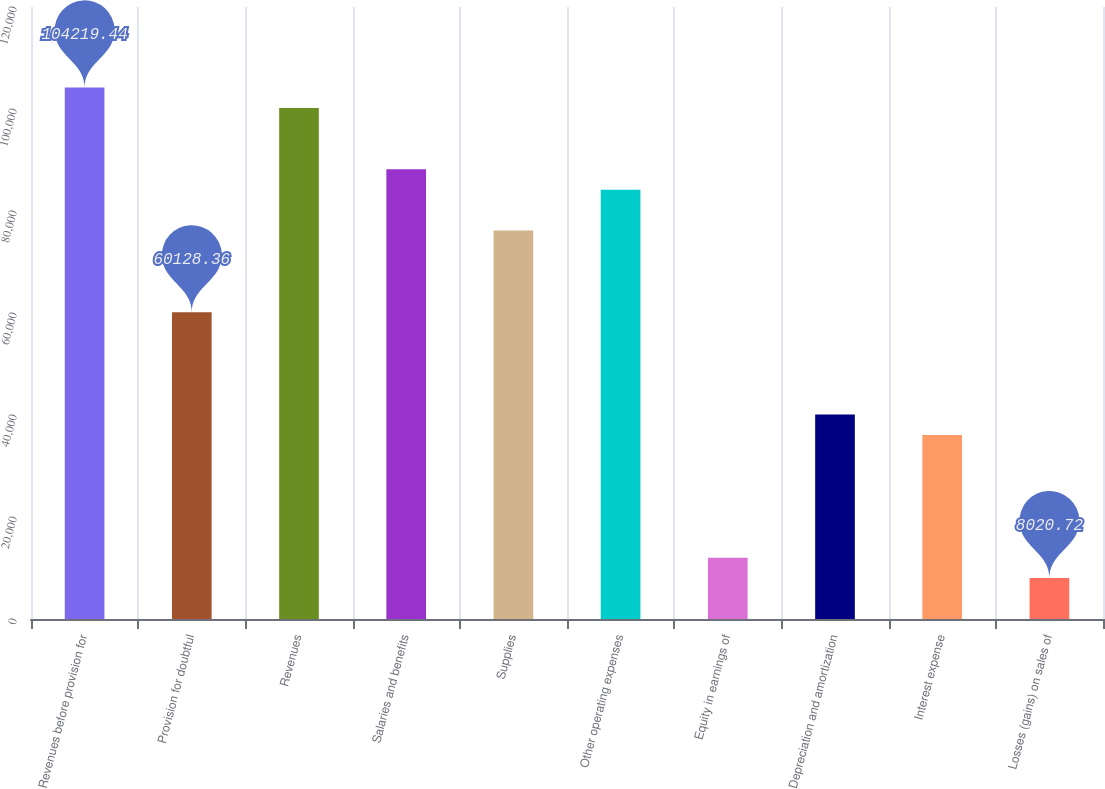<chart> <loc_0><loc_0><loc_500><loc_500><bar_chart><fcel>Revenues before provision for<fcel>Provision for doubtful<fcel>Revenues<fcel>Salaries and benefits<fcel>Supplies<fcel>Other operating expenses<fcel>Equity in earnings of<fcel>Depreciation and amortization<fcel>Interest expense<fcel>Losses (gains) on sales of<nl><fcel>104219<fcel>60128.4<fcel>100211<fcel>88186.3<fcel>76161.5<fcel>84178<fcel>12029<fcel>40087<fcel>36078.7<fcel>8020.72<nl></chart> 